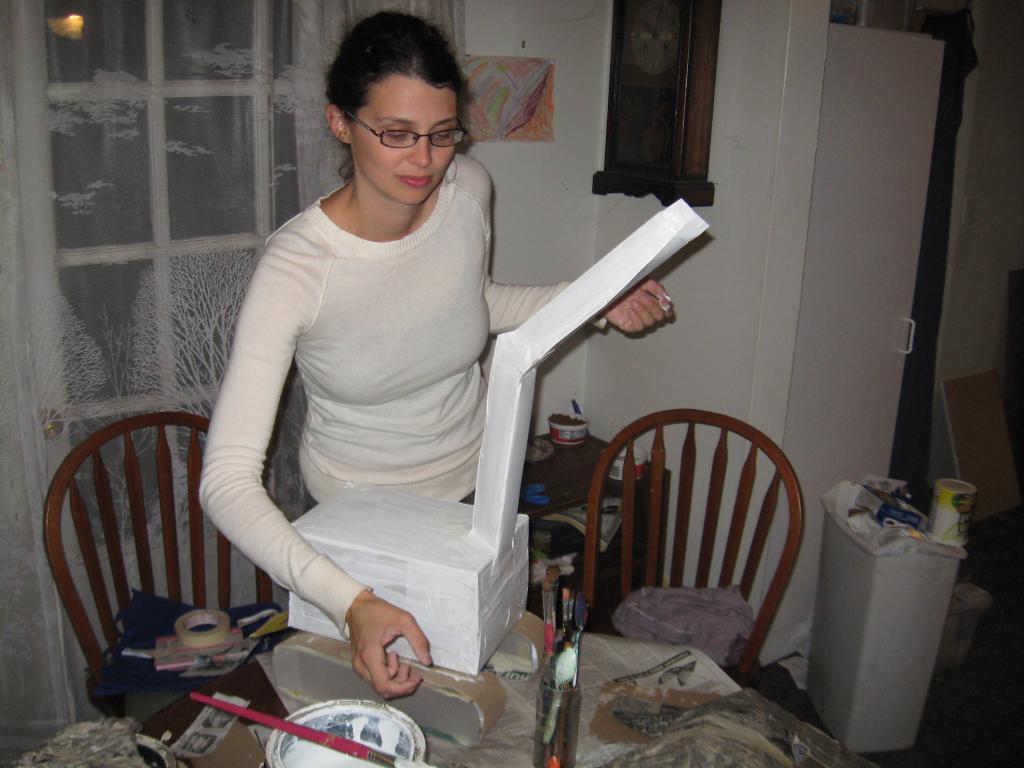Describe this image in one or two sentences. As we can see in the image there is a white color wall, window, woman standing over here and there are chairs and tables. On table there are chairs and a box. 